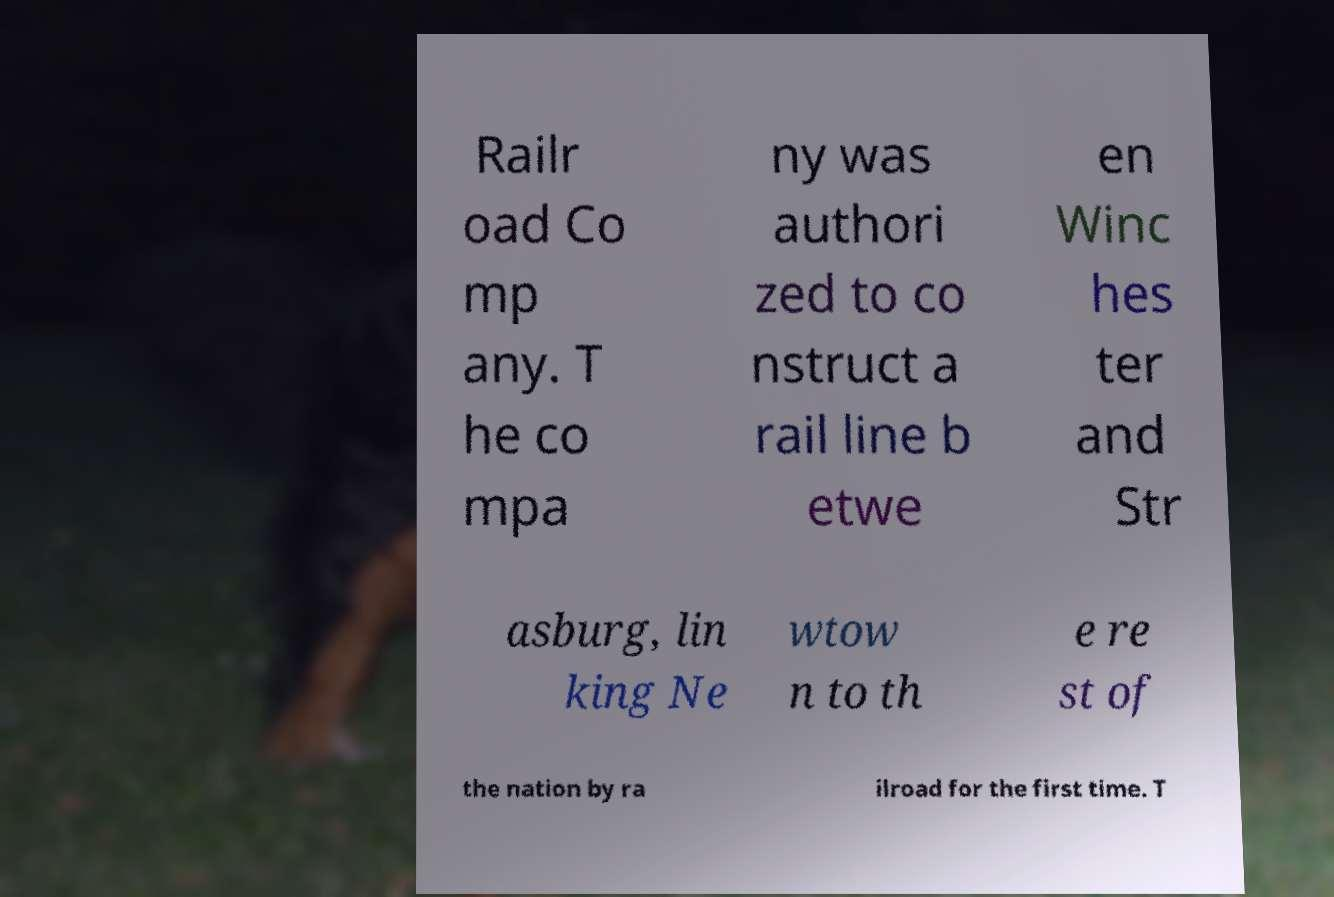Can you read and provide the text displayed in the image?This photo seems to have some interesting text. Can you extract and type it out for me? Railr oad Co mp any. T he co mpa ny was authori zed to co nstruct a rail line b etwe en Winc hes ter and Str asburg, lin king Ne wtow n to th e re st of the nation by ra ilroad for the first time. T 